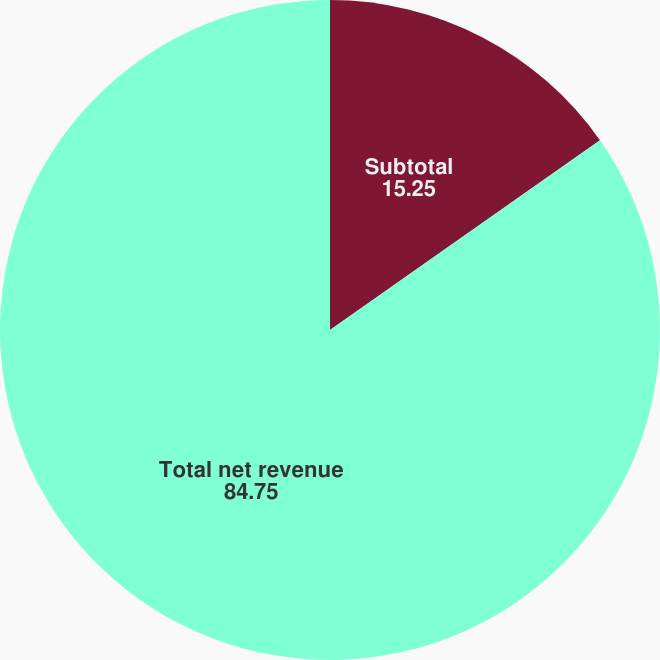Convert chart to OTSL. <chart><loc_0><loc_0><loc_500><loc_500><pie_chart><fcel>Subtotal<fcel>Total net revenue<nl><fcel>15.25%<fcel>84.75%<nl></chart> 